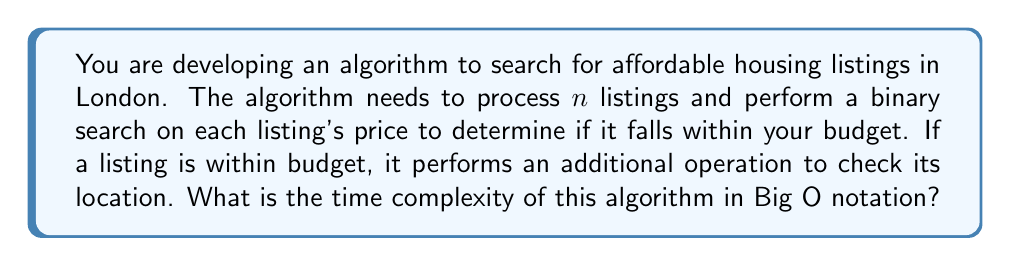Help me with this question. Let's break down the algorithm and analyze its time complexity step by step:

1. Processing $n$ listings:
   This requires iterating through all listings, which takes $O(n)$ time.

2. Binary search on each listing's price:
   - Binary search has a time complexity of $O(\log m)$, where $m$ is the size of the sorted array.
   - In this case, we're performing binary search on the price, which we can assume has a fixed range (e.g., 0 to maximum possible price).
   - Therefore, the time complexity for each binary search is $O(\log p)$, where $p$ is the price range.
   - We perform this binary search for each of the $n$ listings.

3. Additional location check:
   - This is performed only if the listing is within budget.
   - In the worst case, all listings could be within budget.
   - The location check is assumed to be a constant time operation, $O(1)$.

Combining these steps:

- The overall time complexity is: $O(n \cdot (\log p + 1))$
- This simplifies to: $O(n \log p)$

The $+1$ inside the parentheses (representing the constant time location check) doesn't affect the overall Big O complexity, so we can omit it.

Since $p$ (the price range) is a constant and doesn't depend on the input size $n$, we can further simplify the time complexity to $O(n)$.
Answer: $O(n)$ 